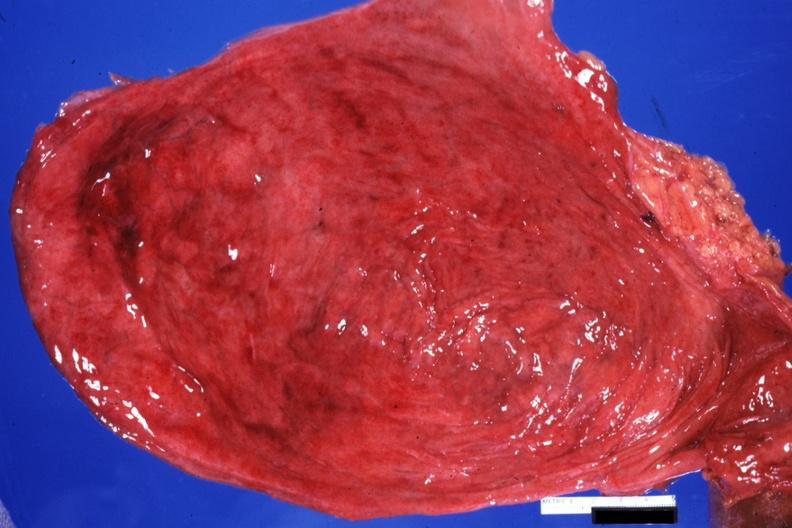does submaxillary gland show opened bladder quite good with diverticula?
Answer the question using a single word or phrase. No 